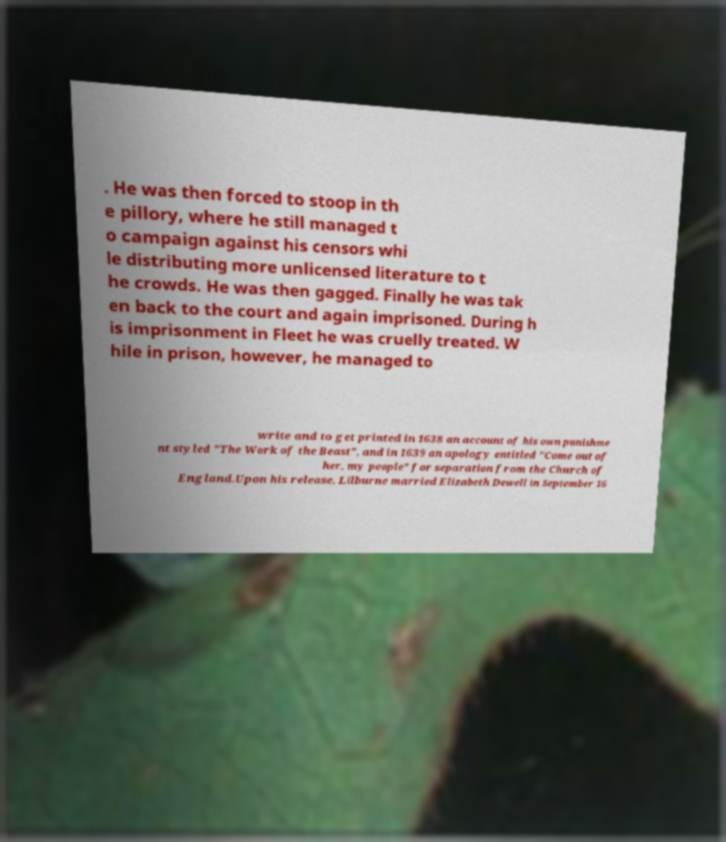Could you extract and type out the text from this image? . He was then forced to stoop in th e pillory, where he still managed t o campaign against his censors whi le distributing more unlicensed literature to t he crowds. He was then gagged. Finally he was tak en back to the court and again imprisoned. During h is imprisonment in Fleet he was cruelly treated. W hile in prison, however, he managed to write and to get printed in 1638 an account of his own punishme nt styled "The Work of the Beast", and in 1639 an apology entitled "Come out of her, my people" for separation from the Church of England.Upon his release, Lilburne married Elizabeth Dewell in September 16 